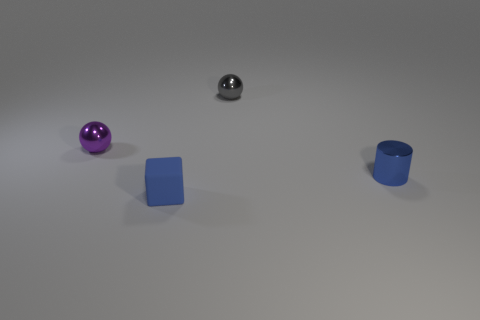Is the number of matte things behind the tiny cylinder the same as the number of small blue cubes?
Offer a terse response. No. What number of tiny cylinders are on the left side of the small shiny object behind the metallic thing on the left side of the tiny gray ball?
Your answer should be compact. 0. The tiny thing that is in front of the small metallic cylinder is what color?
Make the answer very short. Blue. There is a tiny object that is on the right side of the blue block and in front of the small gray object; what is it made of?
Provide a succinct answer. Metal. How many purple metal spheres are in front of the blue object in front of the blue cylinder?
Ensure brevity in your answer.  0. The rubber thing is what shape?
Provide a short and direct response. Cube. What shape is the tiny gray thing that is the same material as the purple object?
Your response must be concise. Sphere. Does the tiny blue thing that is in front of the metallic cylinder have the same shape as the purple shiny thing?
Your answer should be very brief. No. What is the shape of the small thing in front of the blue cylinder?
Offer a terse response. Cube. There is a tiny thing that is the same color as the cylinder; what shape is it?
Offer a terse response. Cube. 